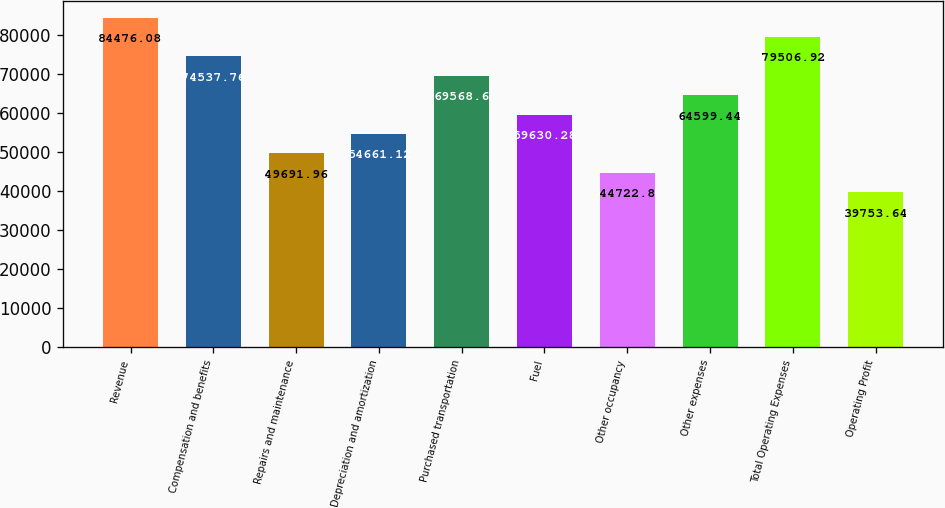Convert chart. <chart><loc_0><loc_0><loc_500><loc_500><bar_chart><fcel>Revenue<fcel>Compensation and benefits<fcel>Repairs and maintenance<fcel>Depreciation and amortization<fcel>Purchased transportation<fcel>Fuel<fcel>Other occupancy<fcel>Other expenses<fcel>Total Operating Expenses<fcel>Operating Profit<nl><fcel>84476.1<fcel>74537.8<fcel>49692<fcel>54661.1<fcel>69568.6<fcel>59630.3<fcel>44722.8<fcel>64599.4<fcel>79506.9<fcel>39753.6<nl></chart> 